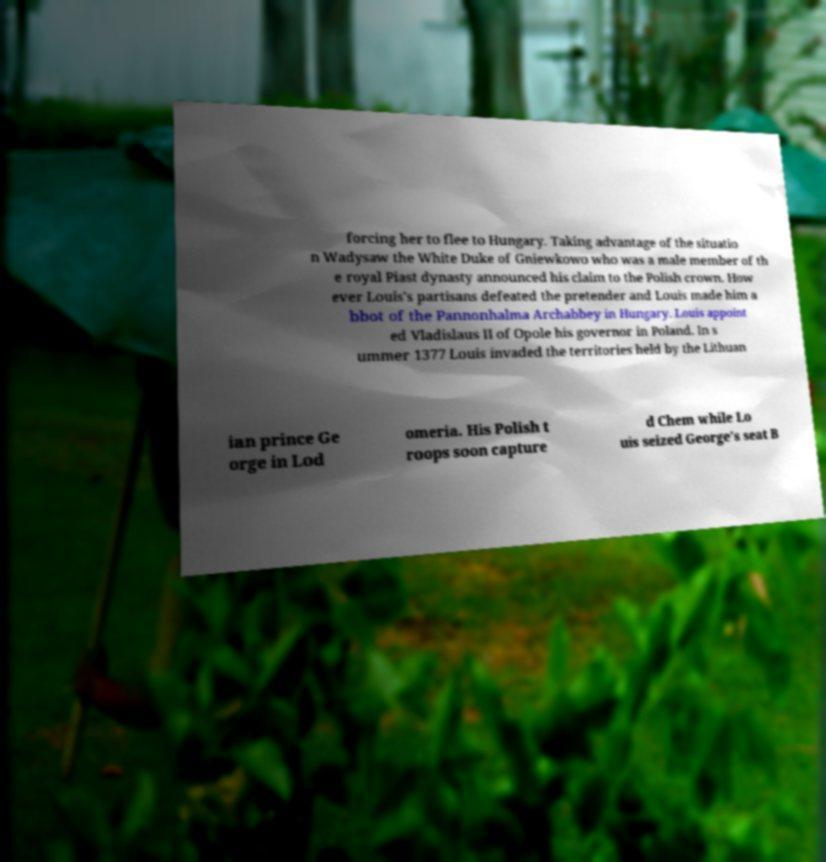What messages or text are displayed in this image? I need them in a readable, typed format. forcing her to flee to Hungary. Taking advantage of the situatio n Wadysaw the White Duke of Gniewkowo who was a male member of th e royal Piast dynasty announced his claim to the Polish crown. How ever Louis's partisans defeated the pretender and Louis made him a bbot of the Pannonhalma Archabbey in Hungary. Louis appoint ed Vladislaus II of Opole his governor in Poland. In s ummer 1377 Louis invaded the territories held by the Lithuan ian prince Ge orge in Lod omeria. His Polish t roops soon capture d Chem while Lo uis seized George's seat B 